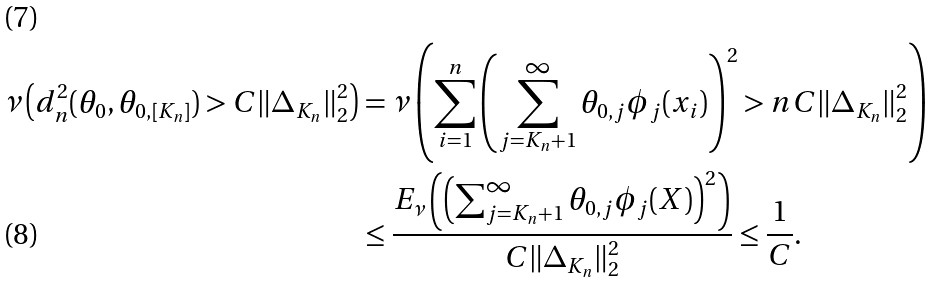<formula> <loc_0><loc_0><loc_500><loc_500>\nu \left ( d _ { n } ^ { 2 } ( \theta _ { 0 } , \theta _ { 0 , [ K _ { n } ] } ) > C \| \Delta _ { K _ { n } } \| _ { 2 } ^ { 2 } \right ) & = \nu \left ( \sum _ { i = 1 } ^ { n } \left ( \sum _ { j = K _ { n } + 1 } ^ { \infty } \theta _ { 0 , j } \phi _ { j } ( x _ { i } ) \right ) ^ { 2 } > n C \| \Delta _ { K _ { n } } \| _ { 2 } ^ { 2 } \right ) \\ & \leq \frac { E _ { \nu } \left ( \left ( \sum _ { j = K _ { n } + 1 } ^ { \infty } \theta _ { 0 , j } \phi _ { j } ( X ) \right ) ^ { 2 } \right ) } { C \| \Delta _ { K _ { n } } \| _ { 2 } ^ { 2 } } \leq \frac { 1 } { C } .</formula> 